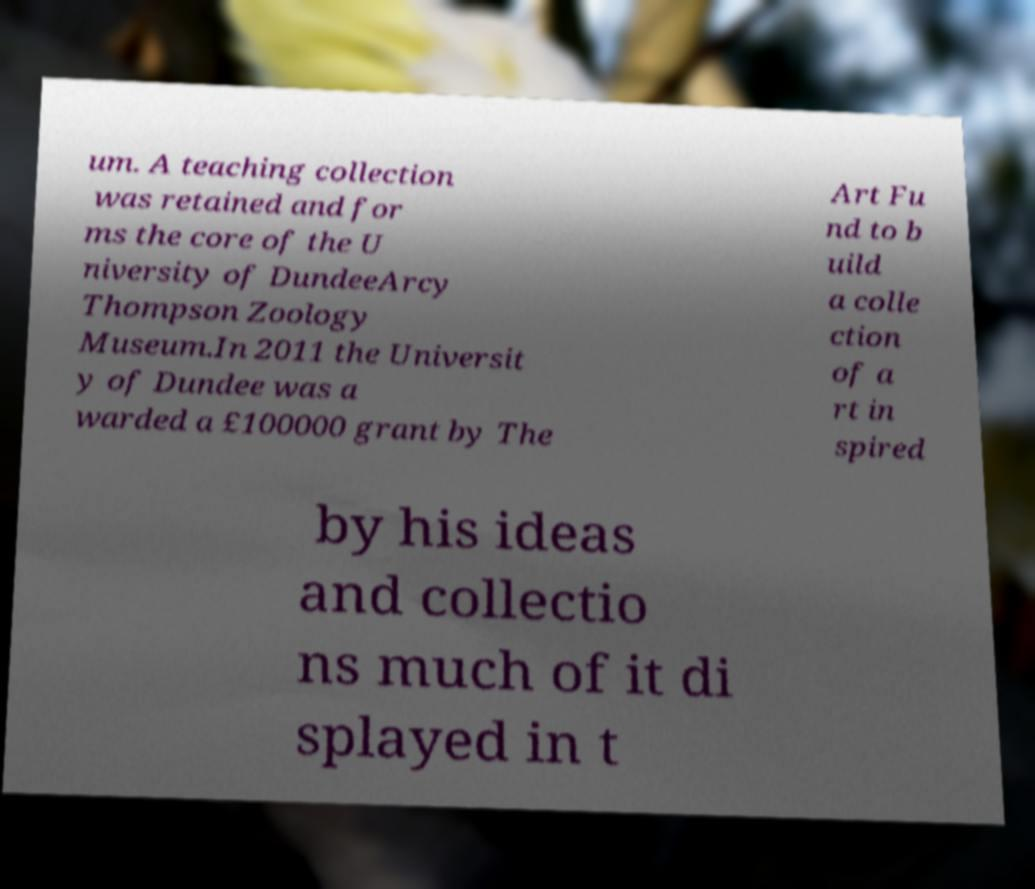Can you accurately transcribe the text from the provided image for me? um. A teaching collection was retained and for ms the core of the U niversity of DundeeArcy Thompson Zoology Museum.In 2011 the Universit y of Dundee was a warded a £100000 grant by The Art Fu nd to b uild a colle ction of a rt in spired by his ideas and collectio ns much of it di splayed in t 